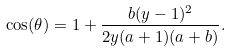Convert formula to latex. <formula><loc_0><loc_0><loc_500><loc_500>\cos ( \theta ) = 1 + \frac { b ( y - 1 ) ^ { 2 } } { 2 y ( a + 1 ) ( a + b ) } .</formula> 